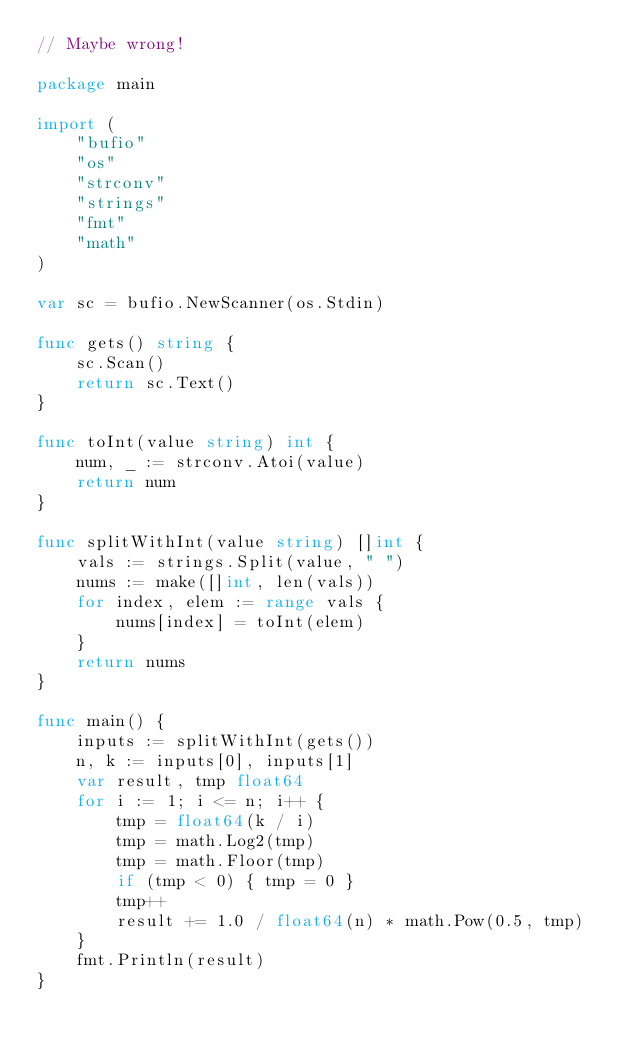<code> <loc_0><loc_0><loc_500><loc_500><_Go_>// Maybe wrong!

package main

import (
    "bufio"
    "os"
    "strconv"
    "strings"
    "fmt"
    "math"
)

var sc = bufio.NewScanner(os.Stdin)

func gets() string {
    sc.Scan()
    return sc.Text()
}

func toInt(value string) int {
    num, _ := strconv.Atoi(value)
    return num
}

func splitWithInt(value string) []int {
    vals := strings.Split(value, " ")
    nums := make([]int, len(vals))
    for index, elem := range vals {
        nums[index] = toInt(elem)
    }
    return nums
}

func main() {
    inputs := splitWithInt(gets())
    n, k := inputs[0], inputs[1]
    var result, tmp float64
    for i := 1; i <= n; i++ {
        tmp = float64(k / i)
        tmp = math.Log2(tmp)
        tmp = math.Floor(tmp)
        if (tmp < 0) { tmp = 0 }
        tmp++
        result += 1.0 / float64(n) * math.Pow(0.5, tmp)
    }
    fmt.Println(result)
}
</code> 